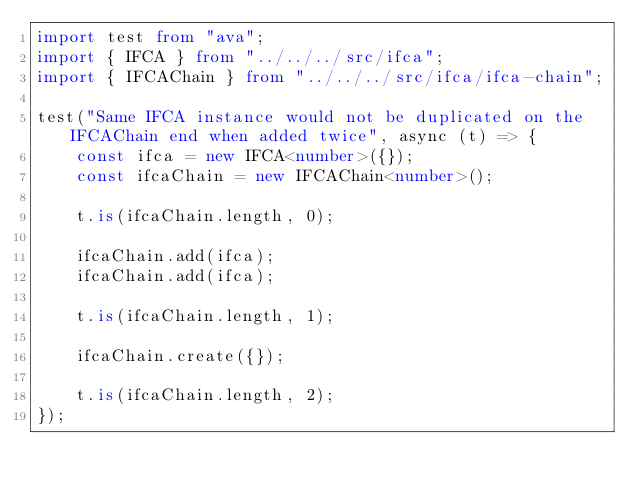Convert code to text. <code><loc_0><loc_0><loc_500><loc_500><_TypeScript_>import test from "ava";
import { IFCA } from "../../../src/ifca";
import { IFCAChain } from "../../../src/ifca/ifca-chain";

test("Same IFCA instance would not be duplicated on the IFCAChain end when added twice", async (t) => {
    const ifca = new IFCA<number>({});
    const ifcaChain = new IFCAChain<number>();

    t.is(ifcaChain.length, 0);

    ifcaChain.add(ifca);
    ifcaChain.add(ifca);

    t.is(ifcaChain.length, 1);

    ifcaChain.create({});

    t.is(ifcaChain.length, 2);
});
</code> 